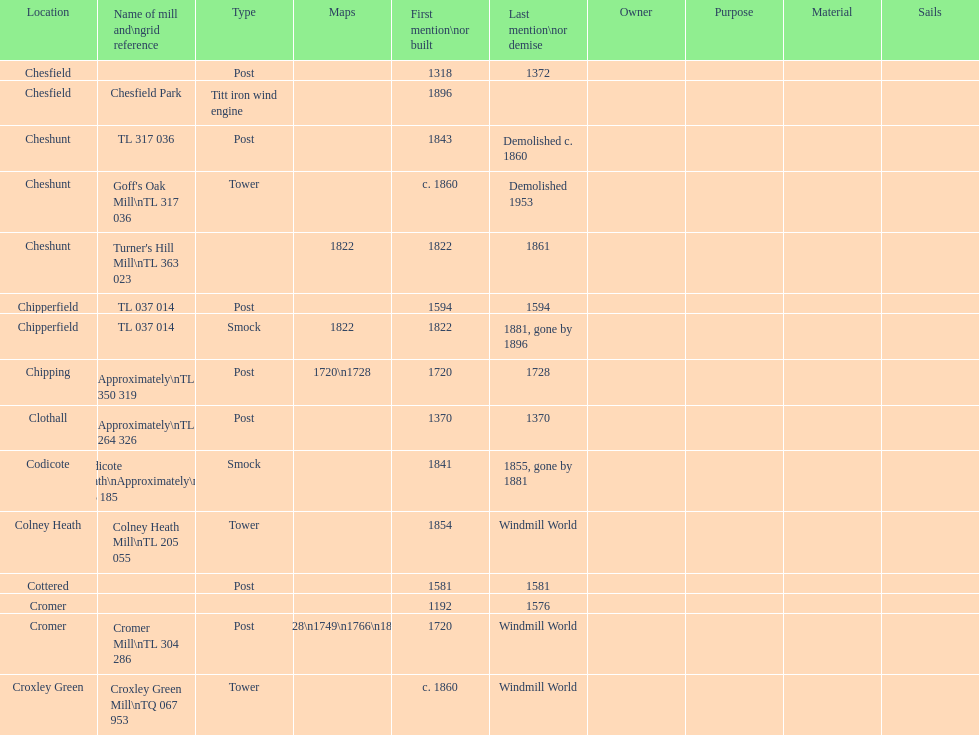How many mills were mentioned or built before 1700? 5. 